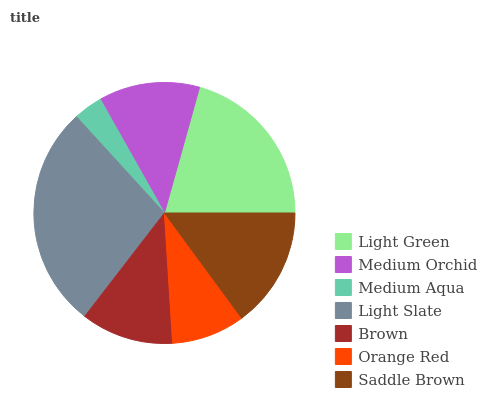Is Medium Aqua the minimum?
Answer yes or no. Yes. Is Light Slate the maximum?
Answer yes or no. Yes. Is Medium Orchid the minimum?
Answer yes or no. No. Is Medium Orchid the maximum?
Answer yes or no. No. Is Light Green greater than Medium Orchid?
Answer yes or no. Yes. Is Medium Orchid less than Light Green?
Answer yes or no. Yes. Is Medium Orchid greater than Light Green?
Answer yes or no. No. Is Light Green less than Medium Orchid?
Answer yes or no. No. Is Medium Orchid the high median?
Answer yes or no. Yes. Is Medium Orchid the low median?
Answer yes or no. Yes. Is Light Green the high median?
Answer yes or no. No. Is Brown the low median?
Answer yes or no. No. 